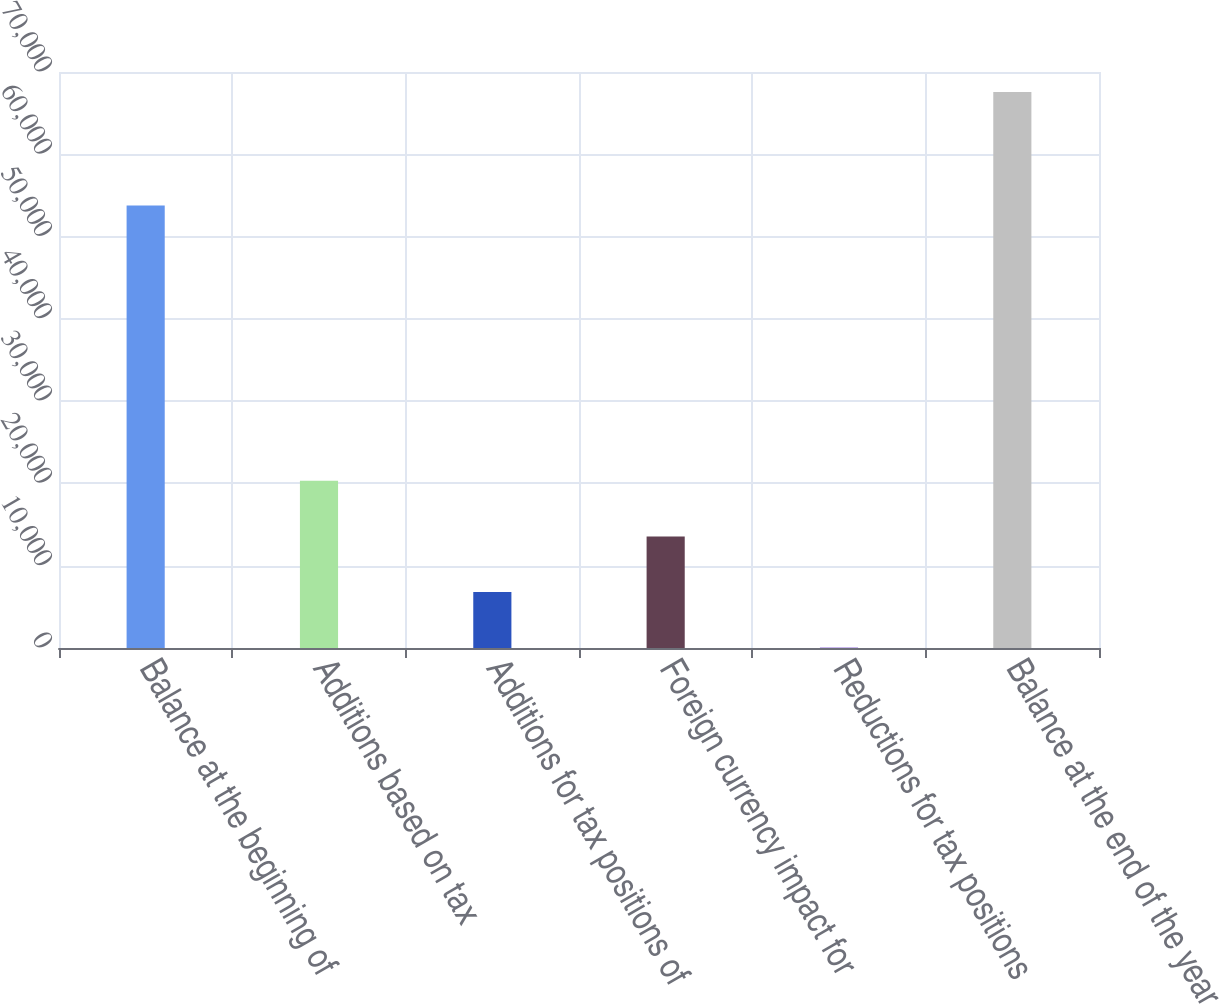Convert chart. <chart><loc_0><loc_0><loc_500><loc_500><bar_chart><fcel>Balance at the beginning of<fcel>Additions based on tax<fcel>Additions for tax positions of<fcel>Foreign currency impact for<fcel>Reductions for tax positions<fcel>Balance at the end of the year<nl><fcel>53763<fcel>20314.8<fcel>6811.6<fcel>13563.2<fcel>60<fcel>67576<nl></chart> 